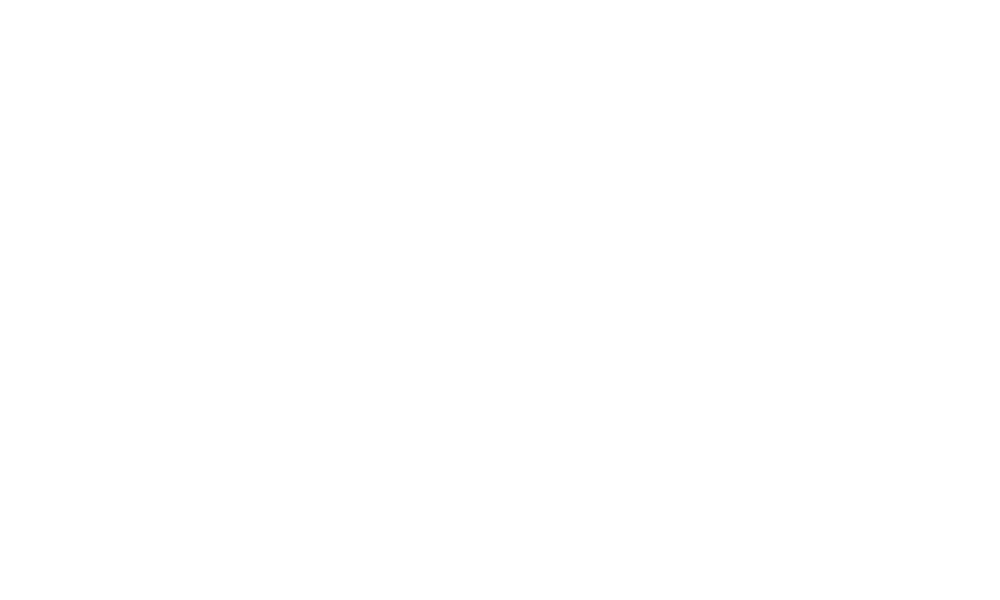Convert chart. <chart><loc_0><loc_0><loc_500><loc_500><pie_chart><fcel>Net income attributable to<nl><fcel>100.0%<nl></chart> 